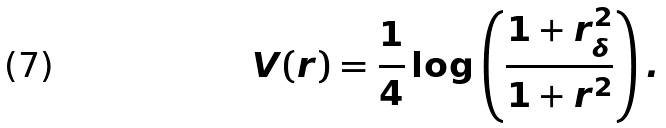Convert formula to latex. <formula><loc_0><loc_0><loc_500><loc_500>V ( r ) = \frac { 1 } { 4 } \log \left ( \frac { 1 + r _ { \delta } ^ { 2 } } { 1 + r ^ { 2 } } \right ) .</formula> 